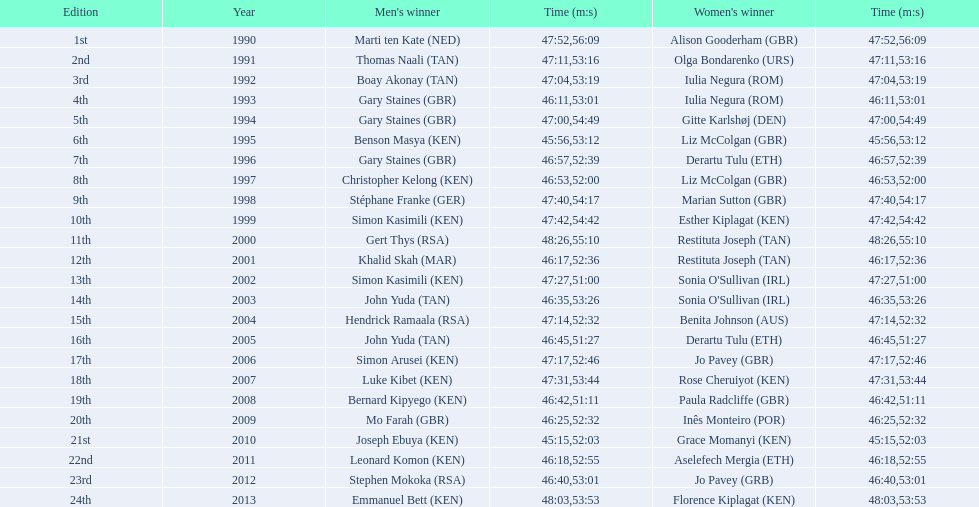In the 2013 bupa great south run, how do the finishing times for men and women compare? 5:50. 